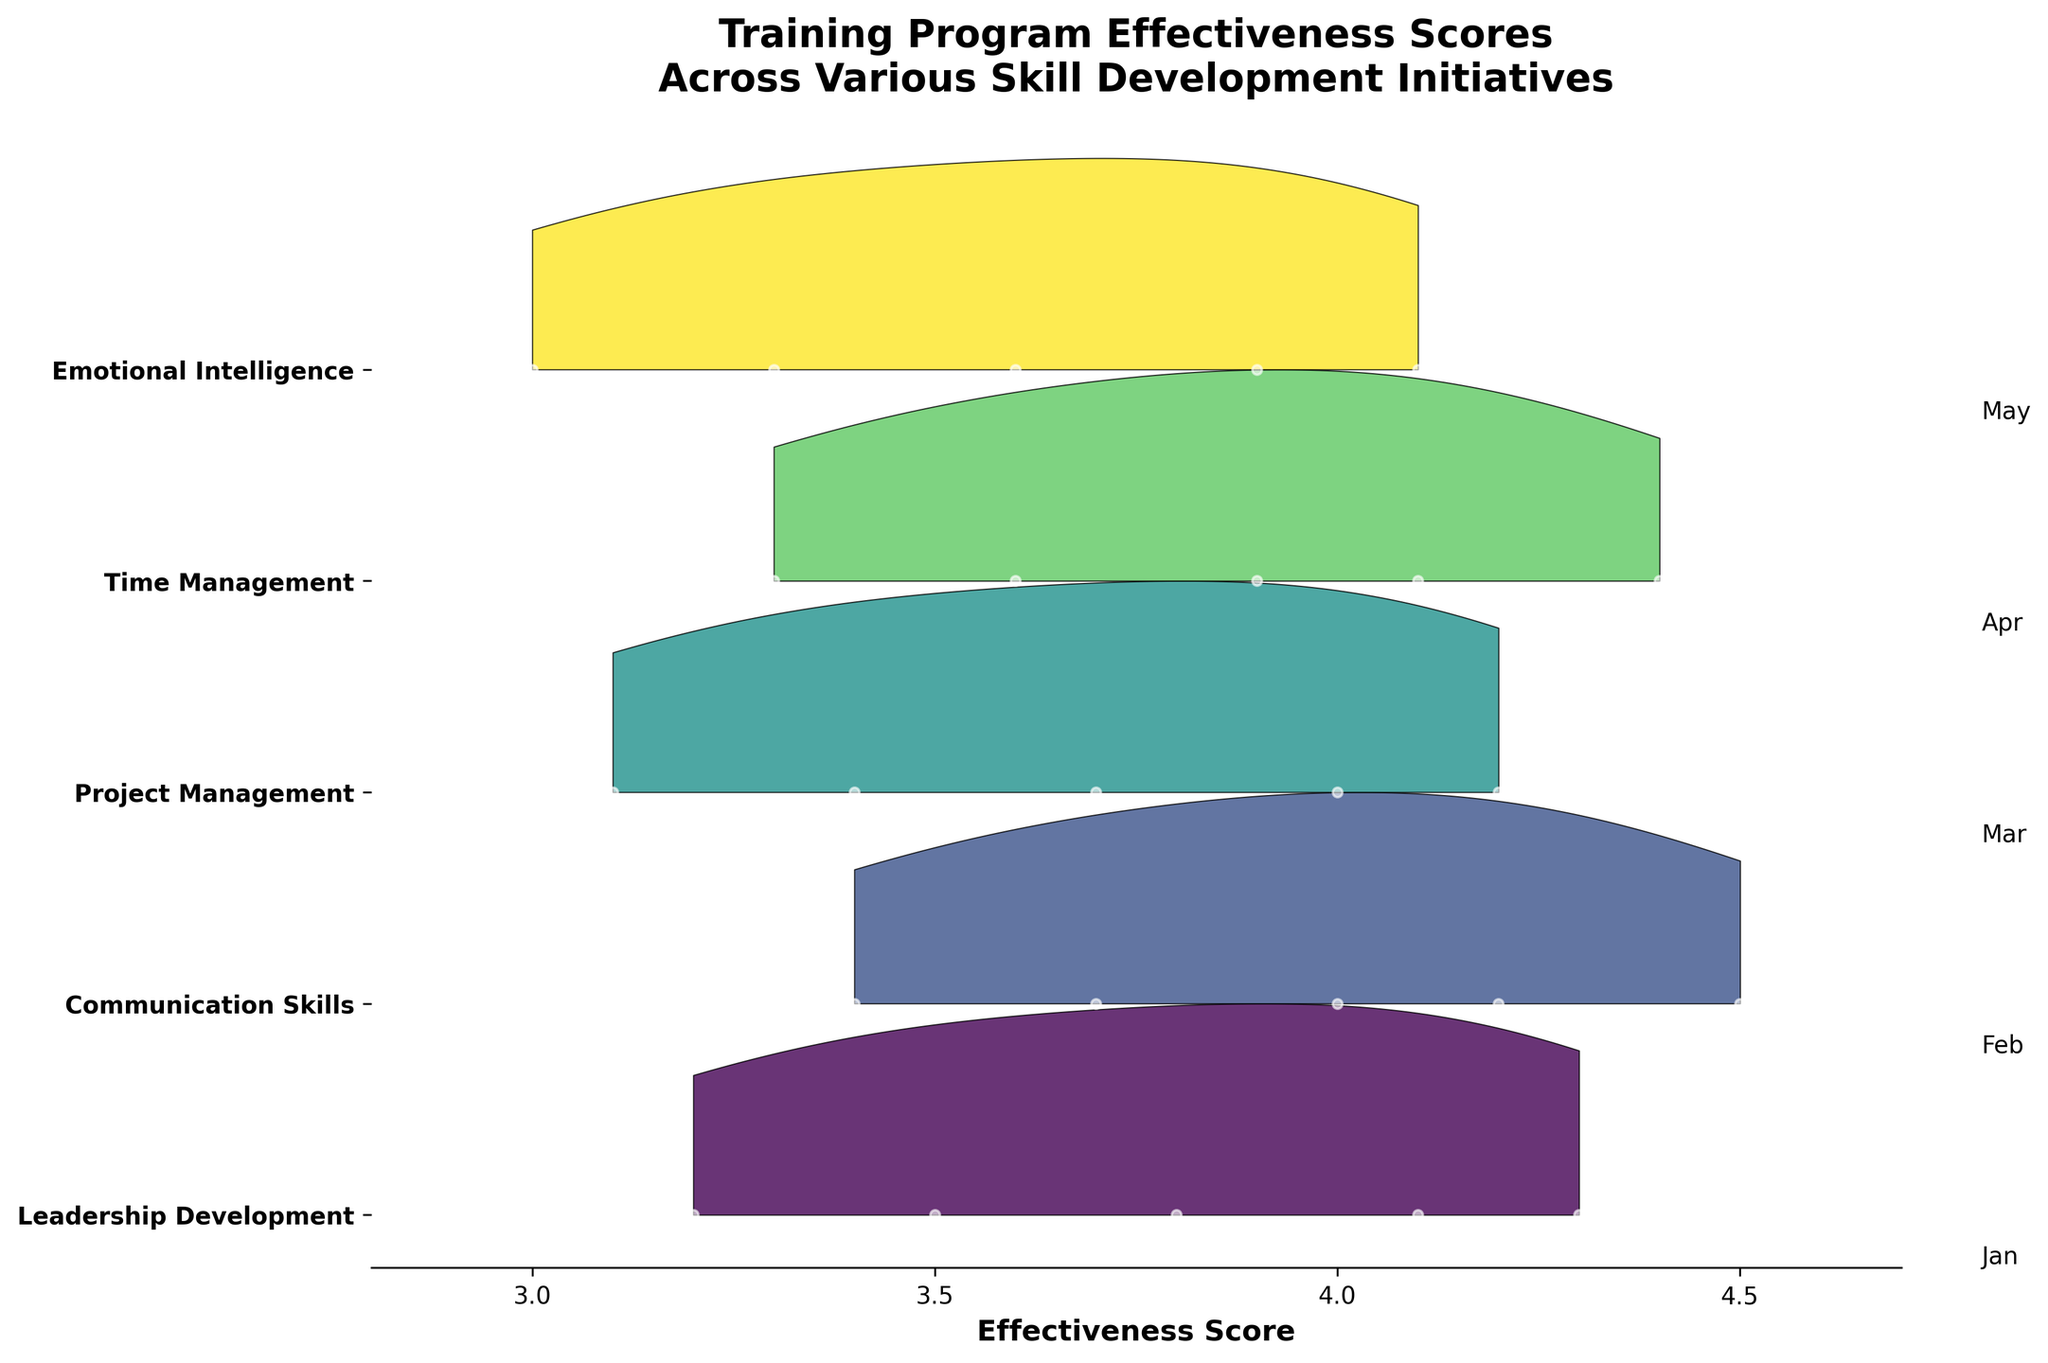What is the title of the figure? The title of a figure is usually located at the top of the plot. In this case, the title is clearly shown there.
Answer: Training Program Effectiveness Scores Across Various Skill Development Initiatives What is the range of the effectiveness score? The effectiveness score ranges from the minimum value on the x-axis to the maximum value on the x-axis. The x-axis starts at 2.8 and ends at 4.7.
Answer: 2.8 to 4.7 Which skill development initiative has the highest effectiveness score in May? To find this, move along the month labels on the right, starting from 'Jan' at the top to 'May' at the bottom. Check which distribution is furthest right on the plot for 'May'.
Answer: Communication Skills Which skill development initiative showed the most improvement from January to May? Calculate the difference between the effectiveness scores in January and May for each skill. The skill with the largest positive difference has shown the most improvement.
Answer: Communication Skills Which two skill development initiatives have overlapping effectiveness scores? Observe the distributions for each skill. Overlapping means they have regions on the x-axis where their density curves intersect or overlap significantly.
Answer: Project Management and Time Management How does the effectiveness score for Leadership Development change from January to May? Trace the points and distributions for Leadership Development month by month from January to May. Note the trend in the central tendency of these distributions.
Answer: It increases steadily What is the effectiveness score distribution trend for Project Management? Look at the density curves for Project Management. The trend can be seen by observing how the curve changes from one month to another.
Answer: It increases monthly Which month has the widest effectiveness score range across all skills? The widest range will be shown by looking for the month where the combined distributions span the largest segment of the x-axis.
Answer: May How does the density of Emotional Intelligence compare to others in January? Observe the height and shape of the density curve for Emotional Intelligence in January compared to the other skills.
Answer: Lower and less concentrated What can you infer from the shape of the ridgeline plot for Communication Skills in April? The shape of the ridgeline plot for Communication Skills in April shows how scores are distributed. A taller peak implies concentrated scores, while a flat, wide distribution implies varied scores.
Answer: Concentrated around a high effectiveness score 